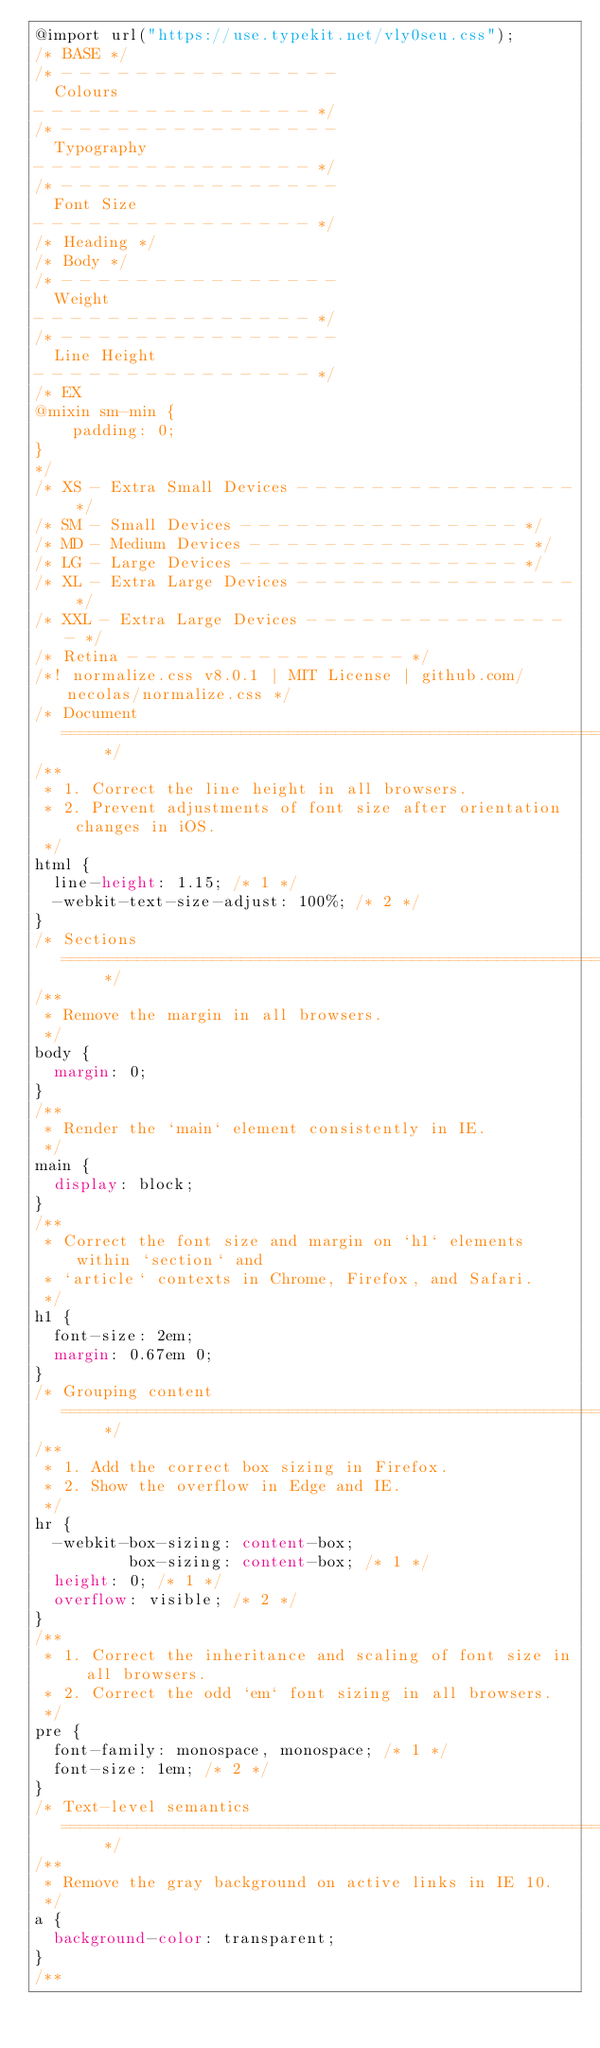<code> <loc_0><loc_0><loc_500><loc_500><_CSS_>@import url("https://use.typekit.net/vly0seu.css");
/* BASE */
/* - - - - - - - - - - - - - - - 
  Colours 
- - - - - - - - - - - - - - - */
/* - - - - - - - - - - - - - - - 
  Typography
- - - - - - - - - - - - - - - */
/* - - - - - - - - - - - - - - - 
  Font Size
- - - - - - - - - - - - - - - */
/* Heading */
/* Body */
/* - - - - - - - - - - - - - - - 
  Weight
- - - - - - - - - - - - - - - */
/* - - - - - - - - - - - - - - - 
  Line Height
- - - - - - - - - - - - - - - */
/* EX
@mixin sm-min {
	padding: 0;
}
*/
/* XS - Extra Small Devices - - - - - - - - - - - - - - - */
/* SM - Small Devices - - - - - - - - - - - - - - - */
/* MD - Medium Devices - - - - - - - - - - - - - - - */
/* LG - Large Devices - - - - - - - - - - - - - - - */
/* XL - Extra Large Devices - - - - - - - - - - - - - - - */
/* XXL - Extra Large Devices - - - - - - - - - - - - - - - */
/* Retina - - - - - - - - - - - - - - - */
/*! normalize.css v8.0.1 | MIT License | github.com/necolas/normalize.css */
/* Document
   ========================================================================== */
/**
 * 1. Correct the line height in all browsers.
 * 2. Prevent adjustments of font size after orientation changes in iOS.
 */
html {
  line-height: 1.15; /* 1 */
  -webkit-text-size-adjust: 100%; /* 2 */
}
/* Sections
   ========================================================================== */
/**
 * Remove the margin in all browsers.
 */
body {
  margin: 0;
}
/**
 * Render the `main` element consistently in IE.
 */
main {
  display: block;
}
/**
 * Correct the font size and margin on `h1` elements within `section` and
 * `article` contexts in Chrome, Firefox, and Safari.
 */
h1 {
  font-size: 2em;
  margin: 0.67em 0;
}
/* Grouping content
   ========================================================================== */
/**
 * 1. Add the correct box sizing in Firefox.
 * 2. Show the overflow in Edge and IE.
 */
hr {
  -webkit-box-sizing: content-box;
          box-sizing: content-box; /* 1 */
  height: 0; /* 1 */
  overflow: visible; /* 2 */
}
/**
 * 1. Correct the inheritance and scaling of font size in all browsers.
 * 2. Correct the odd `em` font sizing in all browsers.
 */
pre {
  font-family: monospace, monospace; /* 1 */
  font-size: 1em; /* 2 */
}
/* Text-level semantics
   ========================================================================== */
/**
 * Remove the gray background on active links in IE 10.
 */
a {
  background-color: transparent;
}
/**</code> 